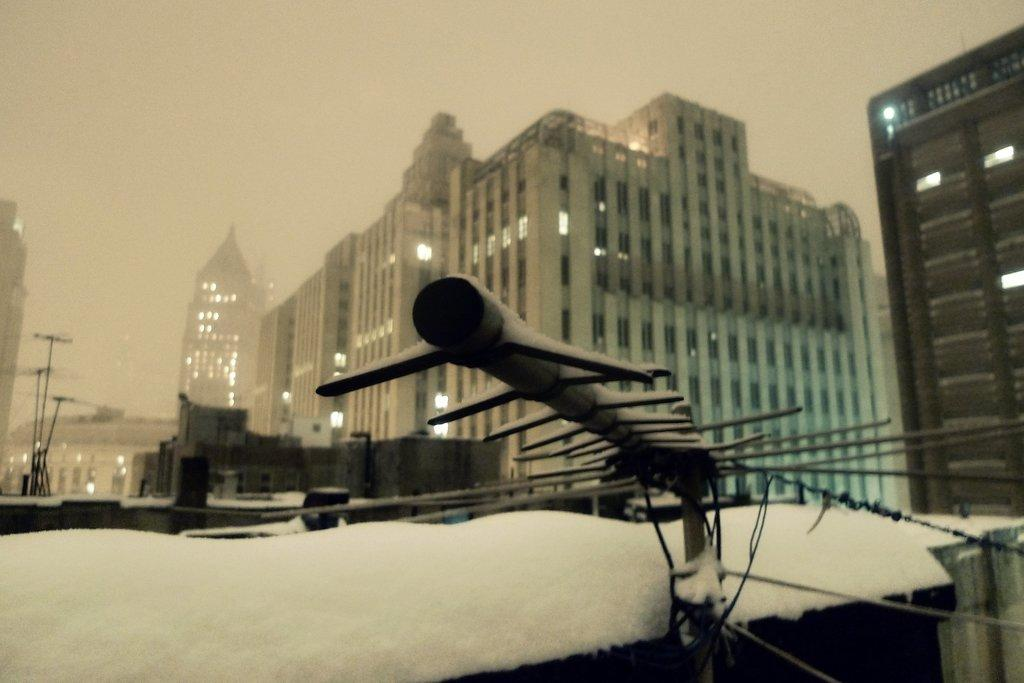What is the main object in the image? There is a pole in the image. Are there any other objects related to the pole? Yes, there are wires in the image. What can be seen in the background of the image? There are buildings in the background of the image. Are there any other poles visible in the image? Yes, there are additional poles on the left side of the image. What type of yam is being cooked on the pole in the image? There is no yam or cooking activity present in the image; it features a pole with wires and additional poles in the background. 